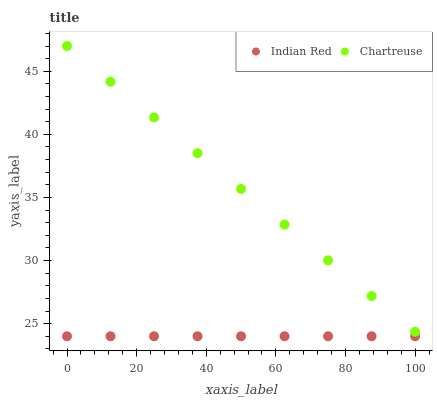Does Indian Red have the minimum area under the curve?
Answer yes or no. Yes. Does Chartreuse have the maximum area under the curve?
Answer yes or no. Yes. Does Indian Red have the maximum area under the curve?
Answer yes or no. No. Is Indian Red the smoothest?
Answer yes or no. Yes. Is Chartreuse the roughest?
Answer yes or no. Yes. Is Indian Red the roughest?
Answer yes or no. No. Does Indian Red have the lowest value?
Answer yes or no. Yes. Does Chartreuse have the highest value?
Answer yes or no. Yes. Does Indian Red have the highest value?
Answer yes or no. No. Is Indian Red less than Chartreuse?
Answer yes or no. Yes. Is Chartreuse greater than Indian Red?
Answer yes or no. Yes. Does Indian Red intersect Chartreuse?
Answer yes or no. No. 